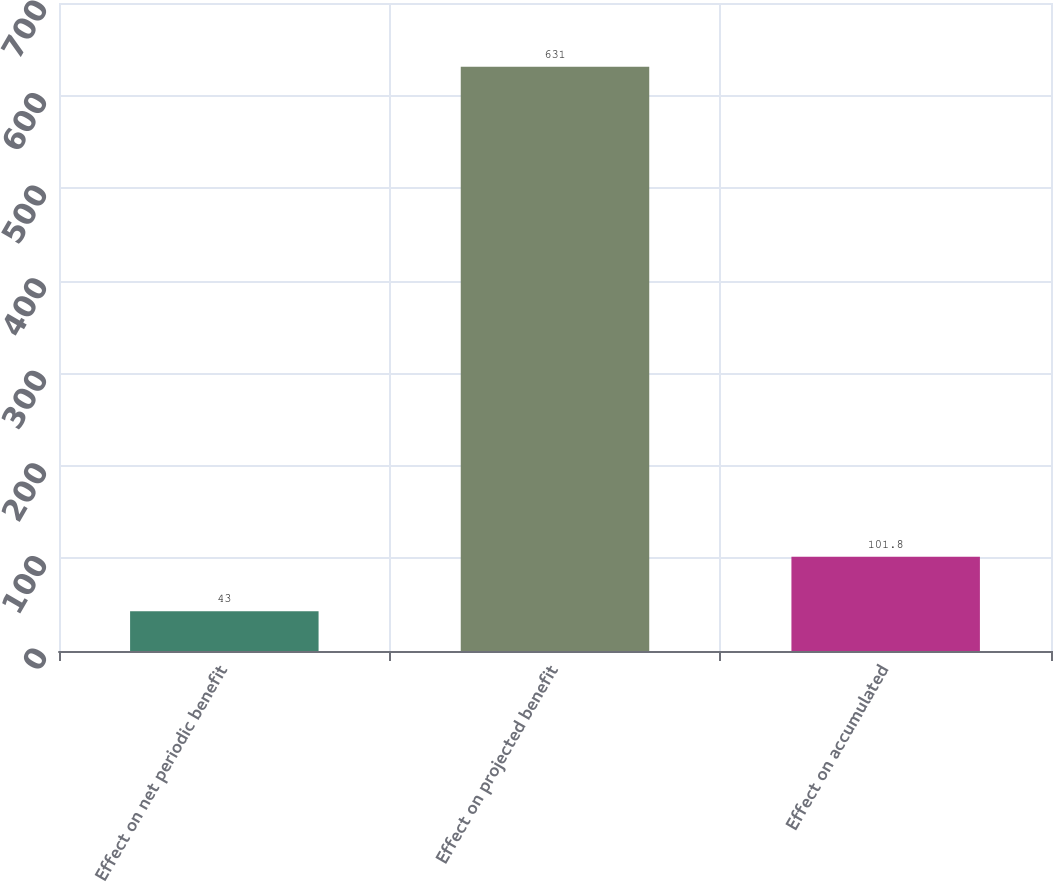Convert chart. <chart><loc_0><loc_0><loc_500><loc_500><bar_chart><fcel>Effect on net periodic benefit<fcel>Effect on projected benefit<fcel>Effect on accumulated<nl><fcel>43<fcel>631<fcel>101.8<nl></chart> 